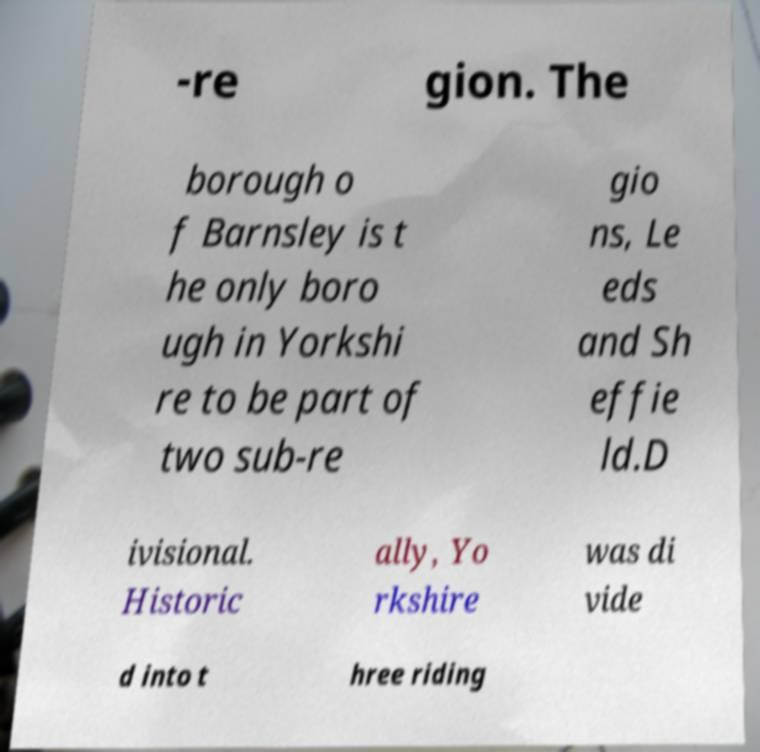Please read and relay the text visible in this image. What does it say? -re gion. The borough o f Barnsley is t he only boro ugh in Yorkshi re to be part of two sub-re gio ns, Le eds and Sh effie ld.D ivisional. Historic ally, Yo rkshire was di vide d into t hree riding 